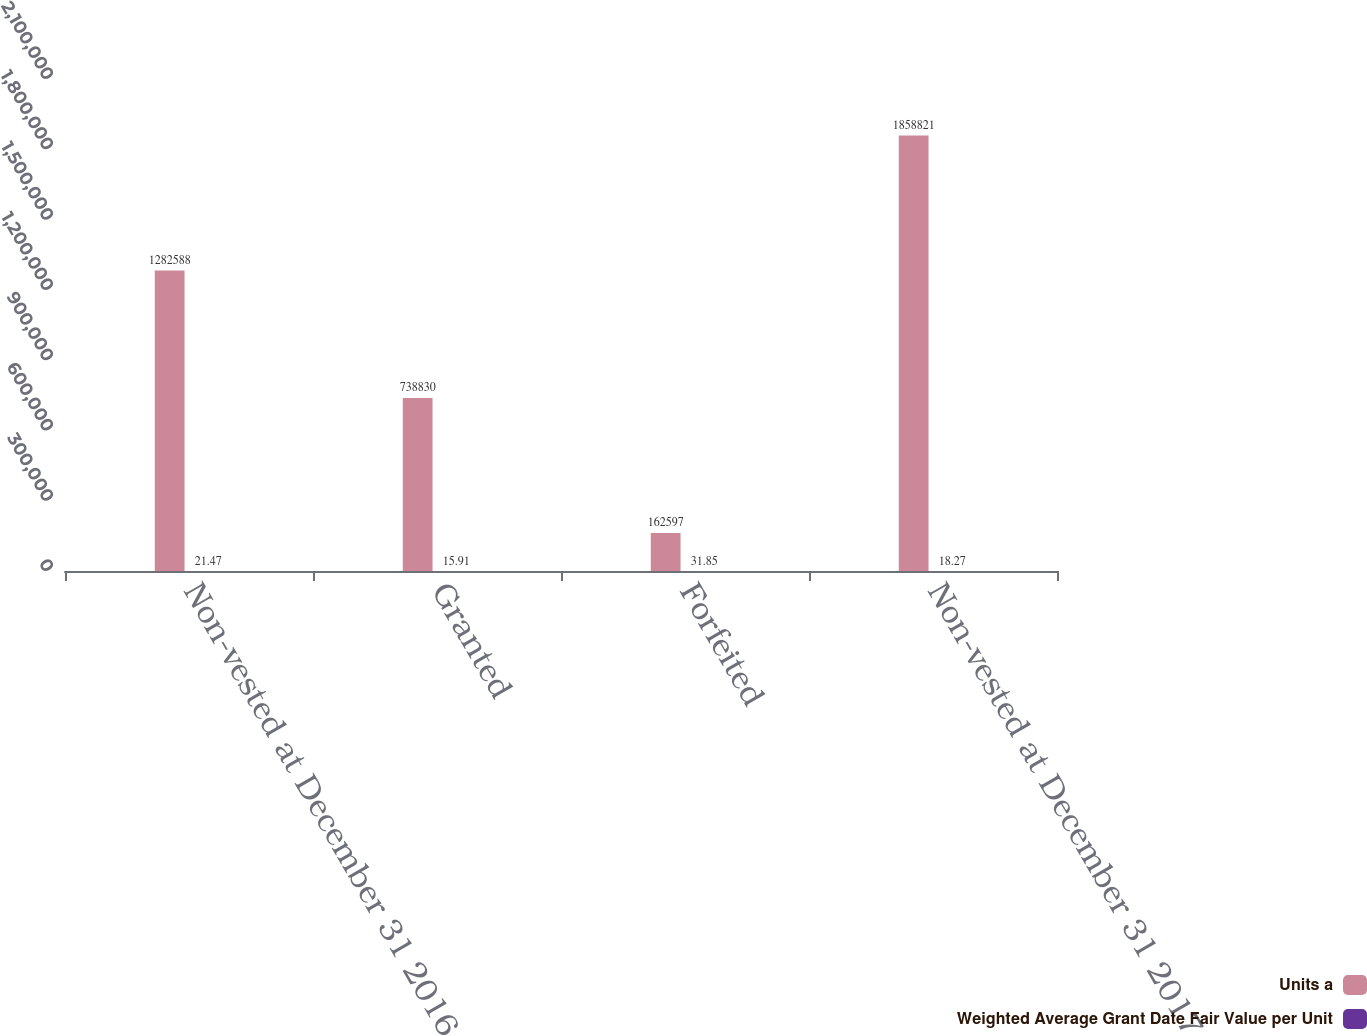Convert chart to OTSL. <chart><loc_0><loc_0><loc_500><loc_500><stacked_bar_chart><ecel><fcel>Non-vested at December 31 2016<fcel>Granted<fcel>Forfeited<fcel>Non-vested at December 31 2017<nl><fcel>Units a<fcel>1.28259e+06<fcel>738830<fcel>162597<fcel>1.85882e+06<nl><fcel>Weighted Average Grant Date Fair Value per Unit<fcel>21.47<fcel>15.91<fcel>31.85<fcel>18.27<nl></chart> 